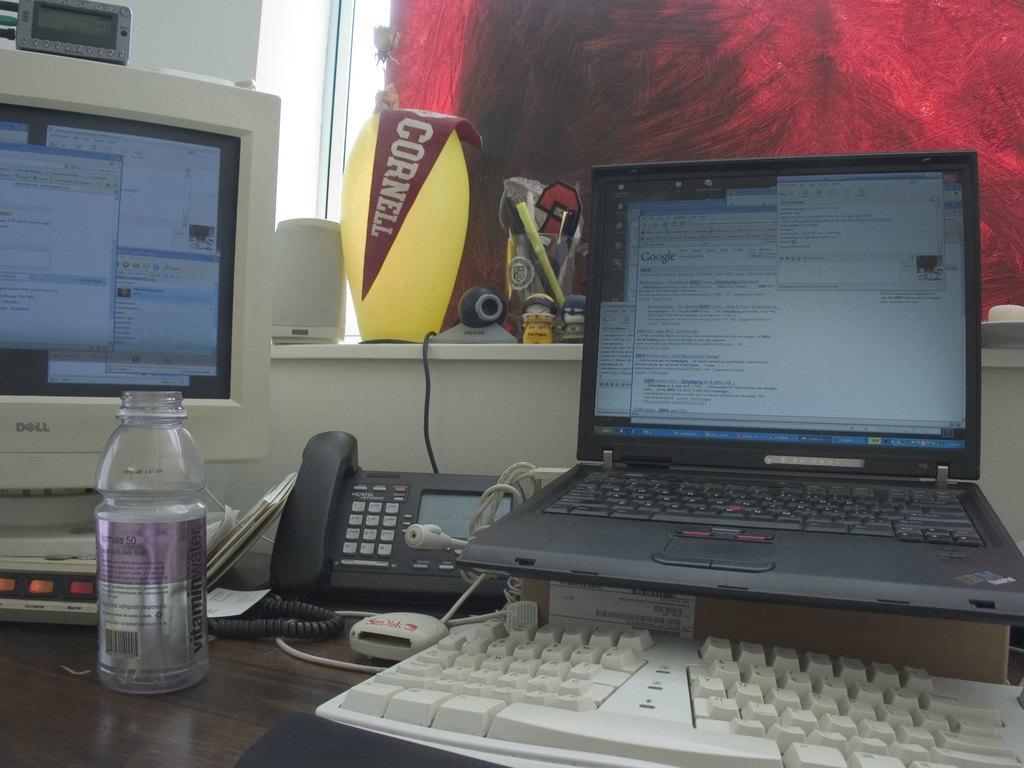Describe this image in one or two sentences. This image consists of a computer, laptop, keyboard, land phone, bottle, pen stand, light, speaker. 